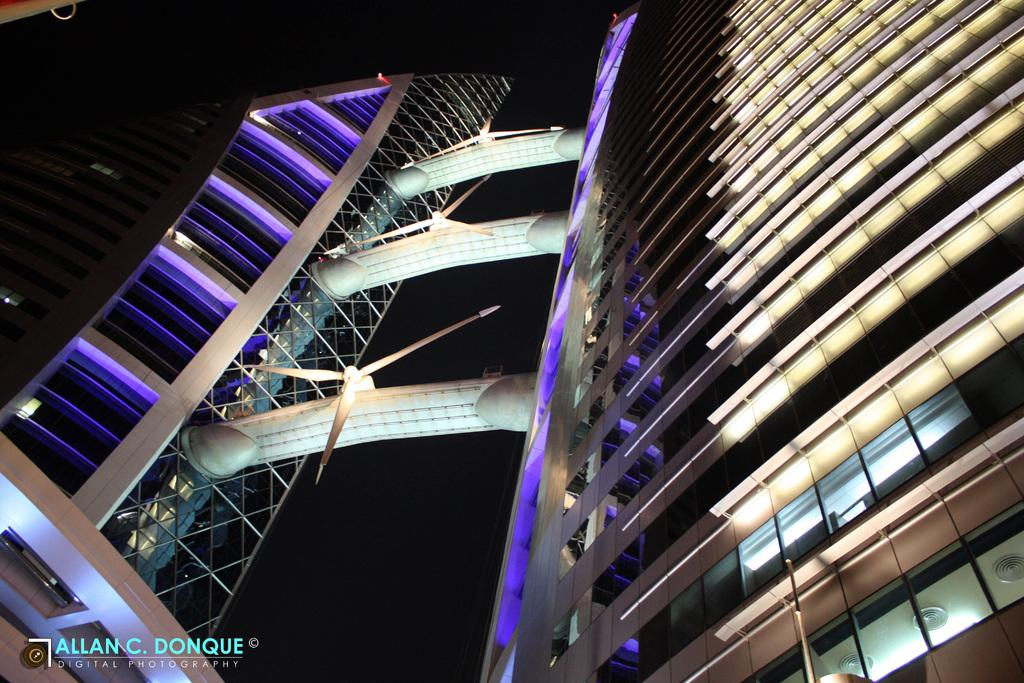What type of structures can be seen in the image? There are buildings in the image. Is there any additional information or marking on the image? Yes, there is a watermark in the image. How would you describe the overall appearance of the image? The background of the image is dark. Can you tell me how many grains of rice are visible in the image? There are no grains of rice present in the image. Is there a friend in the image? There is no friend visible in the image; it only features buildings, a watermark, and a dark background. 